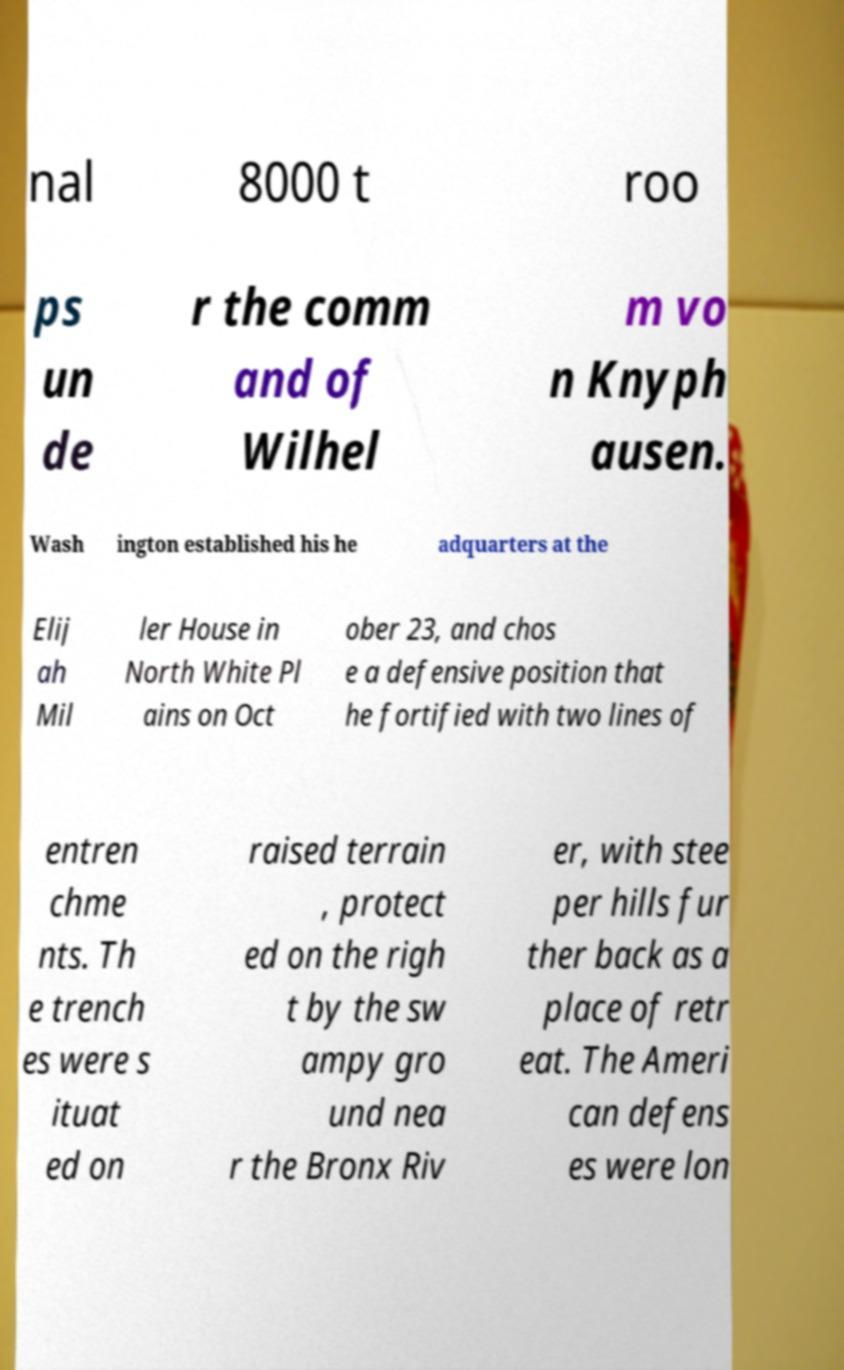What messages or text are displayed in this image? I need them in a readable, typed format. nal 8000 t roo ps un de r the comm and of Wilhel m vo n Knyph ausen. Wash ington established his he adquarters at the Elij ah Mil ler House in North White Pl ains on Oct ober 23, and chos e a defensive position that he fortified with two lines of entren chme nts. Th e trench es were s ituat ed on raised terrain , protect ed on the righ t by the sw ampy gro und nea r the Bronx Riv er, with stee per hills fur ther back as a place of retr eat. The Ameri can defens es were lon 